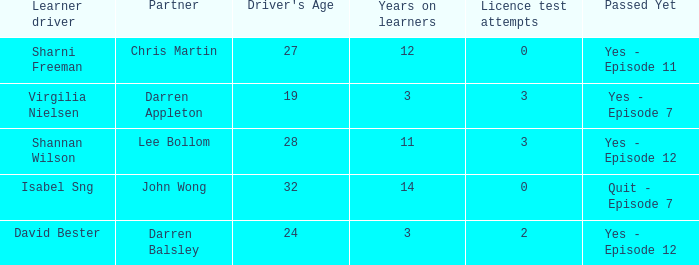Which driver is older than 24 and has more than 0 licence test attempts? Shannan Wilson. 